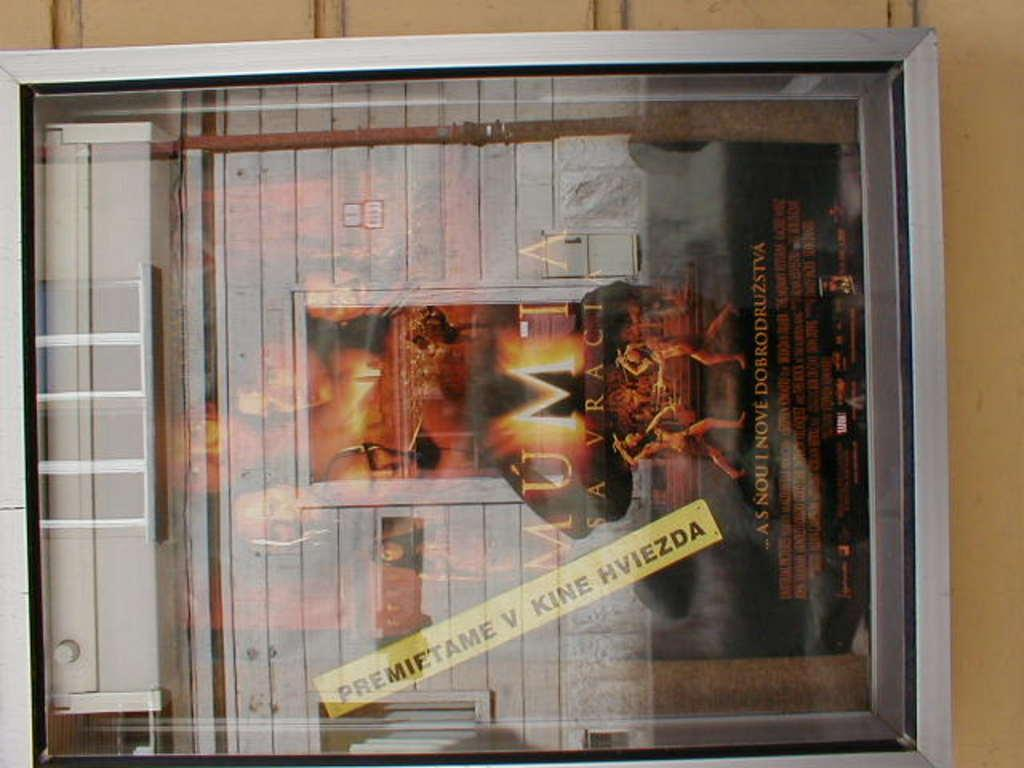What is the main object in the image? There is a glass board in the image. What is on the glass board? There is a poster on the glass board. What color is the surface to which the glass board is attached? The glass board is attached to a yellow surface. How many hammers can be seen on the glass board in the image? There are no hammers present in the image. What type of change is depicted on the poster on the glass board? There is no change depicted on the poster in the image, as it is not mentioned in the provided facts. 